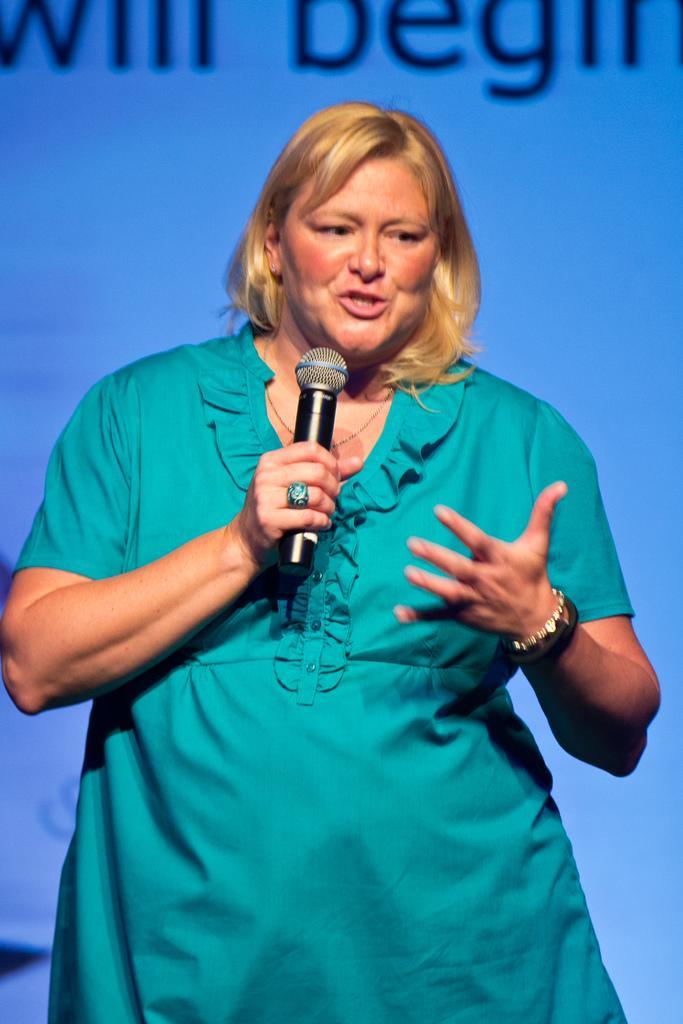Describe this image in one or two sentences. In this image a woman is standing on the stage holding a mic in her hand and talking. At the background there is a poster with a text on it. 